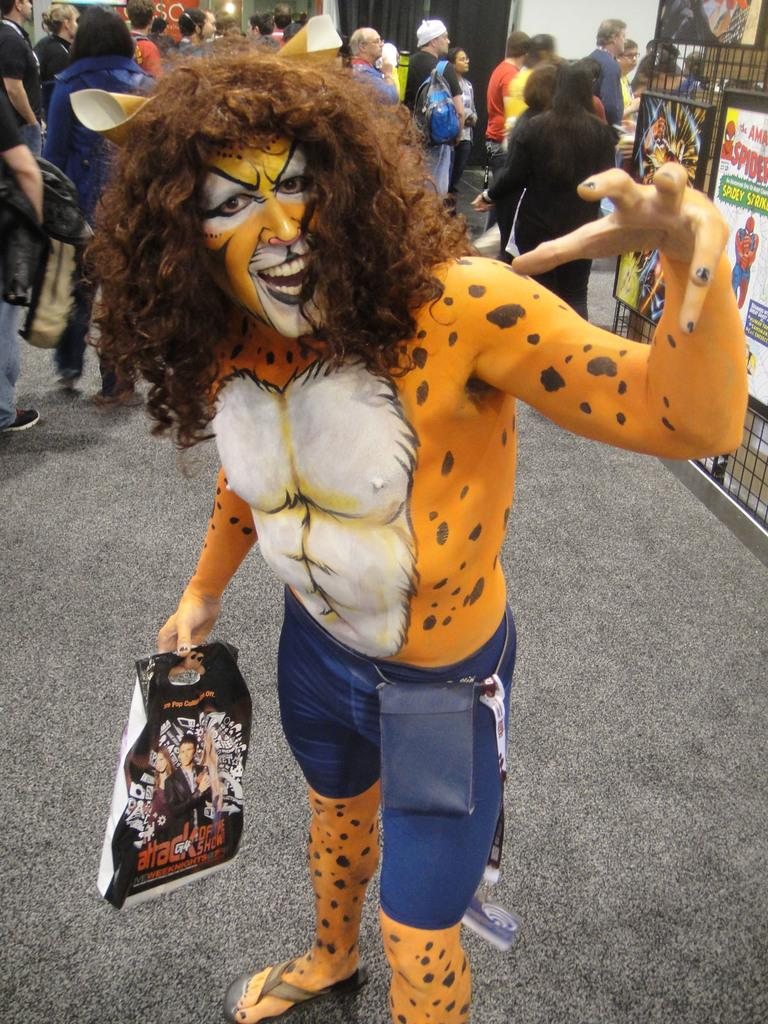What is the person in the image holding? The person in the image is holding a bag. What is the person's posture in the image? The person is standing in the image. How is the person dressed in the image? The person is wearing a fancy dress with makeup in the image. What can be seen on the walls in the image? There are posters in the image. What is visible in the background of the image? There are groups of people in the background of the image. How does the person in the image test the dust particles in the air? There is no mention of dust particles or testing in the image; the focus is on the person holding a bag and their attire. 